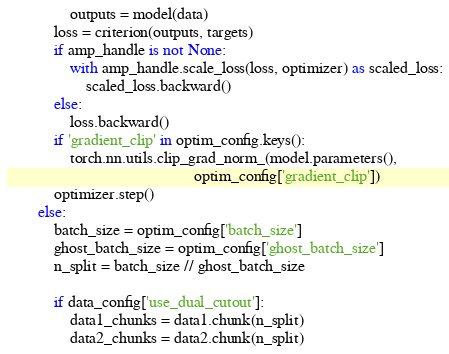<code> <loc_0><loc_0><loc_500><loc_500><_Python_>                outputs = model(data)
            loss = criterion(outputs, targets)
            if amp_handle is not None:
                with amp_handle.scale_loss(loss, optimizer) as scaled_loss:
                    scaled_loss.backward()
            else:
                loss.backward()
            if 'gradient_clip' in optim_config.keys():
                torch.nn.utils.clip_grad_norm_(model.parameters(),
                                               optim_config['gradient_clip'])
            optimizer.step()
        else:
            batch_size = optim_config['batch_size']
            ghost_batch_size = optim_config['ghost_batch_size']
            n_split = batch_size // ghost_batch_size

            if data_config['use_dual_cutout']:
                data1_chunks = data1.chunk(n_split)
                data2_chunks = data2.chunk(n_split)</code> 